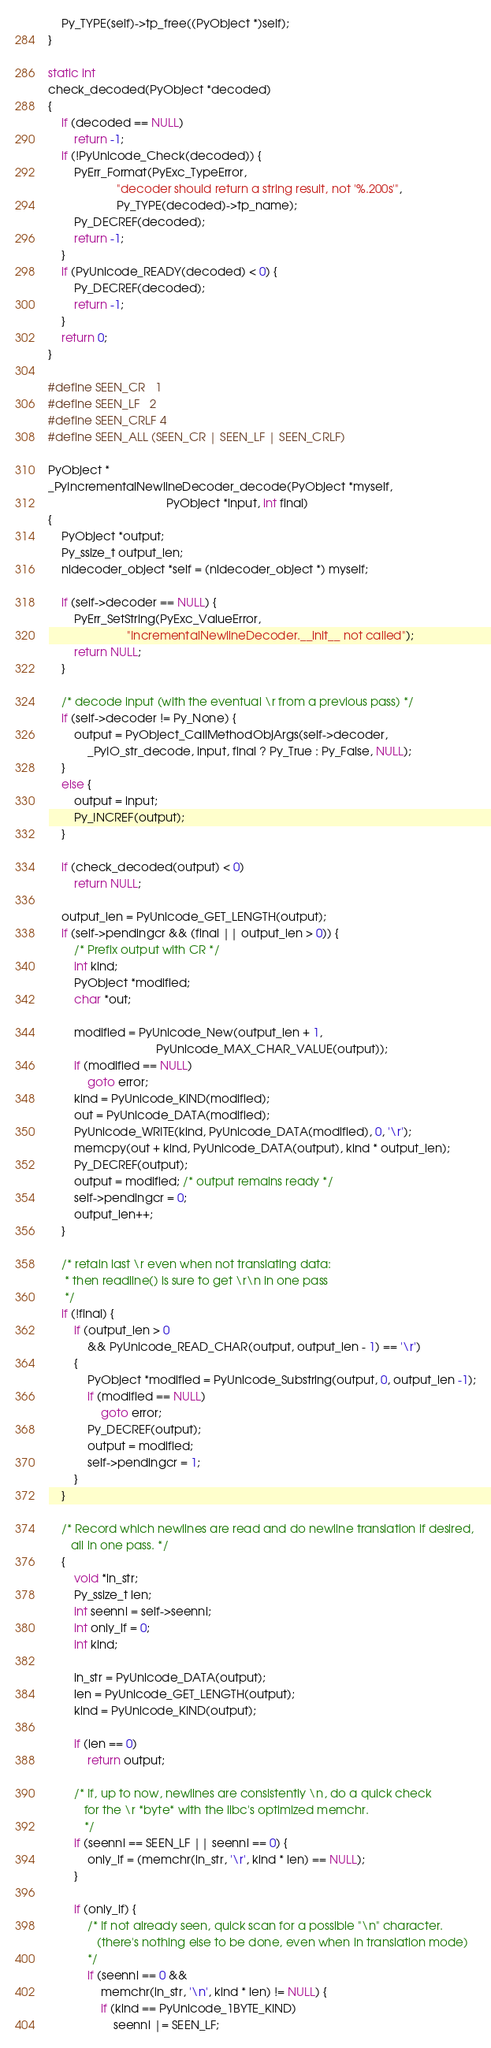<code> <loc_0><loc_0><loc_500><loc_500><_C_>    Py_TYPE(self)->tp_free((PyObject *)self);
}

static int
check_decoded(PyObject *decoded)
{
    if (decoded == NULL)
        return -1;
    if (!PyUnicode_Check(decoded)) {
        PyErr_Format(PyExc_TypeError,
                     "decoder should return a string result, not '%.200s'",
                     Py_TYPE(decoded)->tp_name);
        Py_DECREF(decoded);
        return -1;
    }
    if (PyUnicode_READY(decoded) < 0) {
        Py_DECREF(decoded);
        return -1;
    }
    return 0;
}

#define SEEN_CR   1
#define SEEN_LF   2
#define SEEN_CRLF 4
#define SEEN_ALL (SEEN_CR | SEEN_LF | SEEN_CRLF)

PyObject *
_PyIncrementalNewlineDecoder_decode(PyObject *myself,
                                    PyObject *input, int final)
{
    PyObject *output;
    Py_ssize_t output_len;
    nldecoder_object *self = (nldecoder_object *) myself;

    if (self->decoder == NULL) {
        PyErr_SetString(PyExc_ValueError,
                        "IncrementalNewlineDecoder.__init__ not called");
        return NULL;
    }

    /* decode input (with the eventual \r from a previous pass) */
    if (self->decoder != Py_None) {
        output = PyObject_CallMethodObjArgs(self->decoder,
            _PyIO_str_decode, input, final ? Py_True : Py_False, NULL);
    }
    else {
        output = input;
        Py_INCREF(output);
    }

    if (check_decoded(output) < 0)
        return NULL;

    output_len = PyUnicode_GET_LENGTH(output);
    if (self->pendingcr && (final || output_len > 0)) {
        /* Prefix output with CR */
        int kind;
        PyObject *modified;
        char *out;

        modified = PyUnicode_New(output_len + 1,
                                 PyUnicode_MAX_CHAR_VALUE(output));
        if (modified == NULL)
            goto error;
        kind = PyUnicode_KIND(modified);
        out = PyUnicode_DATA(modified);
        PyUnicode_WRITE(kind, PyUnicode_DATA(modified), 0, '\r');
        memcpy(out + kind, PyUnicode_DATA(output), kind * output_len);
        Py_DECREF(output);
        output = modified; /* output remains ready */
        self->pendingcr = 0;
        output_len++;
    }

    /* retain last \r even when not translating data:
     * then readline() is sure to get \r\n in one pass
     */
    if (!final) {
        if (output_len > 0
            && PyUnicode_READ_CHAR(output, output_len - 1) == '\r')
        {
            PyObject *modified = PyUnicode_Substring(output, 0, output_len -1);
            if (modified == NULL)
                goto error;
            Py_DECREF(output);
            output = modified;
            self->pendingcr = 1;
        }
    }

    /* Record which newlines are read and do newline translation if desired,
       all in one pass. */
    {
        void *in_str;
        Py_ssize_t len;
        int seennl = self->seennl;
        int only_lf = 0;
        int kind;

        in_str = PyUnicode_DATA(output);
        len = PyUnicode_GET_LENGTH(output);
        kind = PyUnicode_KIND(output);

        if (len == 0)
            return output;

        /* If, up to now, newlines are consistently \n, do a quick check
           for the \r *byte* with the libc's optimized memchr.
           */
        if (seennl == SEEN_LF || seennl == 0) {
            only_lf = (memchr(in_str, '\r', kind * len) == NULL);
        }

        if (only_lf) {
            /* If not already seen, quick scan for a possible "\n" character.
               (there's nothing else to be done, even when in translation mode)
            */
            if (seennl == 0 &&
                memchr(in_str, '\n', kind * len) != NULL) {
                if (kind == PyUnicode_1BYTE_KIND)
                    seennl |= SEEN_LF;</code> 